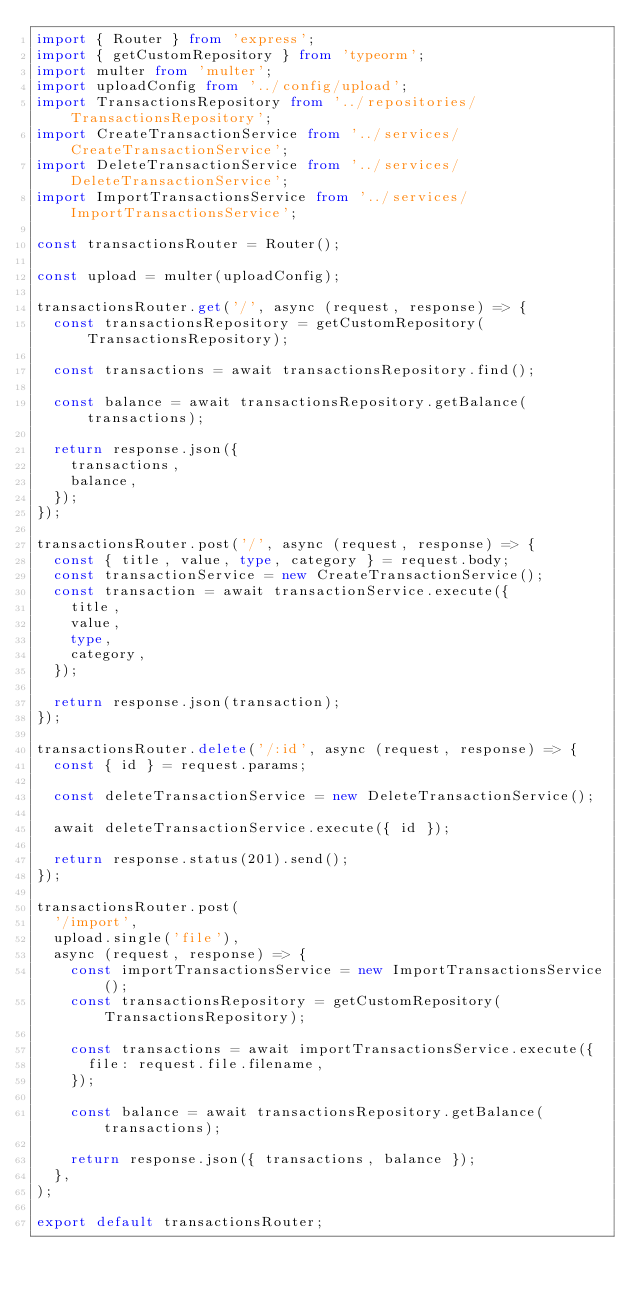<code> <loc_0><loc_0><loc_500><loc_500><_TypeScript_>import { Router } from 'express';
import { getCustomRepository } from 'typeorm';
import multer from 'multer';
import uploadConfig from '../config/upload';
import TransactionsRepository from '../repositories/TransactionsRepository';
import CreateTransactionService from '../services/CreateTransactionService';
import DeleteTransactionService from '../services/DeleteTransactionService';
import ImportTransactionsService from '../services/ImportTransactionsService';

const transactionsRouter = Router();

const upload = multer(uploadConfig);

transactionsRouter.get('/', async (request, response) => {
  const transactionsRepository = getCustomRepository(TransactionsRepository);

  const transactions = await transactionsRepository.find();

  const balance = await transactionsRepository.getBalance(transactions);

  return response.json({
    transactions,
    balance,
  });
});

transactionsRouter.post('/', async (request, response) => {
  const { title, value, type, category } = request.body;
  const transactionService = new CreateTransactionService();
  const transaction = await transactionService.execute({
    title,
    value,
    type,
    category,
  });

  return response.json(transaction);
});

transactionsRouter.delete('/:id', async (request, response) => {
  const { id } = request.params;

  const deleteTransactionService = new DeleteTransactionService();

  await deleteTransactionService.execute({ id });

  return response.status(201).send();
});

transactionsRouter.post(
  '/import',
  upload.single('file'),
  async (request, response) => {
    const importTransactionsService = new ImportTransactionsService();
    const transactionsRepository = getCustomRepository(TransactionsRepository);

    const transactions = await importTransactionsService.execute({
      file: request.file.filename,
    });

    const balance = await transactionsRepository.getBalance(transactions);

    return response.json({ transactions, balance });
  },
);

export default transactionsRouter;
</code> 